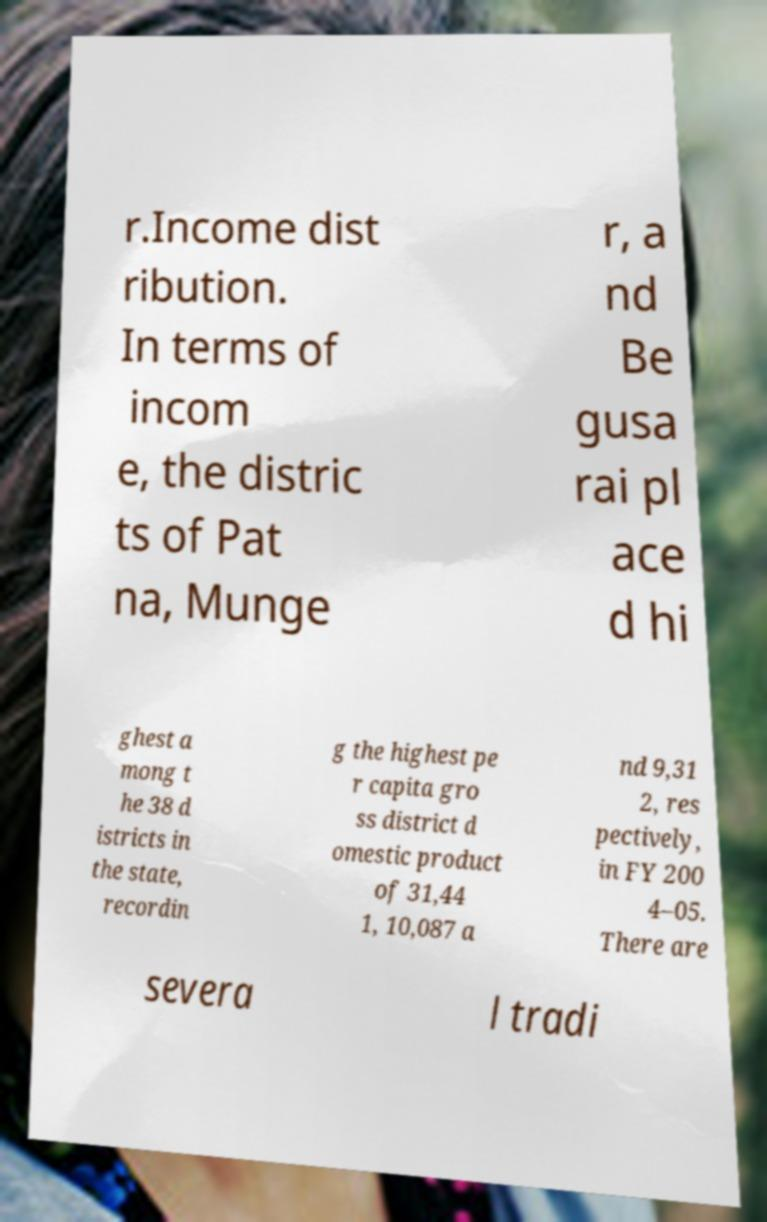Can you read and provide the text displayed in the image?This photo seems to have some interesting text. Can you extract and type it out for me? r.Income dist ribution. In terms of incom e, the distric ts of Pat na, Munge r, a nd Be gusa rai pl ace d hi ghest a mong t he 38 d istricts in the state, recordin g the highest pe r capita gro ss district d omestic product of 31,44 1, 10,087 a nd 9,31 2, res pectively, in FY 200 4–05. There are severa l tradi 